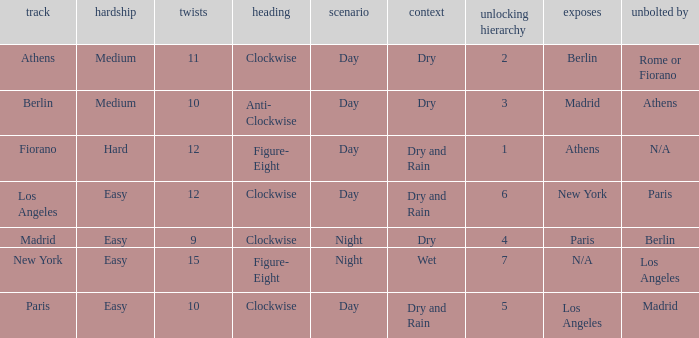Can you parse all the data within this table? {'header': ['track', 'hardship', 'twists', 'heading', 'scenario', 'context', 'unlocking hierarchy', 'exposes', 'unbolted by'], 'rows': [['Athens', 'Medium', '11', 'Clockwise', 'Day', 'Dry', '2', 'Berlin', 'Rome or Fiorano'], ['Berlin', 'Medium', '10', 'Anti- Clockwise', 'Day', 'Dry', '3', 'Madrid', 'Athens'], ['Fiorano', 'Hard', '12', 'Figure- Eight', 'Day', 'Dry and Rain', '1', 'Athens', 'N/A'], ['Los Angeles', 'Easy', '12', 'Clockwise', 'Day', 'Dry and Rain', '6', 'New York', 'Paris'], ['Madrid', 'Easy', '9', 'Clockwise', 'Night', 'Dry', '4', 'Paris', 'Berlin'], ['New York', 'Easy', '15', 'Figure- Eight', 'Night', 'Wet', '7', 'N/A', 'Los Angeles'], ['Paris', 'Easy', '10', 'Clockwise', 'Day', 'Dry and Rain', '5', 'Los Angeles', 'Madrid']]} What is the setting for the hard difficulty? Day. 